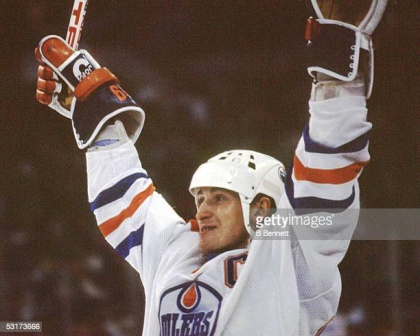What might the player be thinking at this moment? In this moment of triumph, the player is likely overwhelmed with a flood of emotions: exhilaration from the recent victory, pride in his performance, and a deep sense of connection with his team and fans. He might be thinking about the hard work and dedication that led to this point, cherishing the culmination of his efforts and the support of his teammates. Thoughts of gratitude towards his coaches, family, and supporters might also be surfacing as he basks in the glory of the moment. 